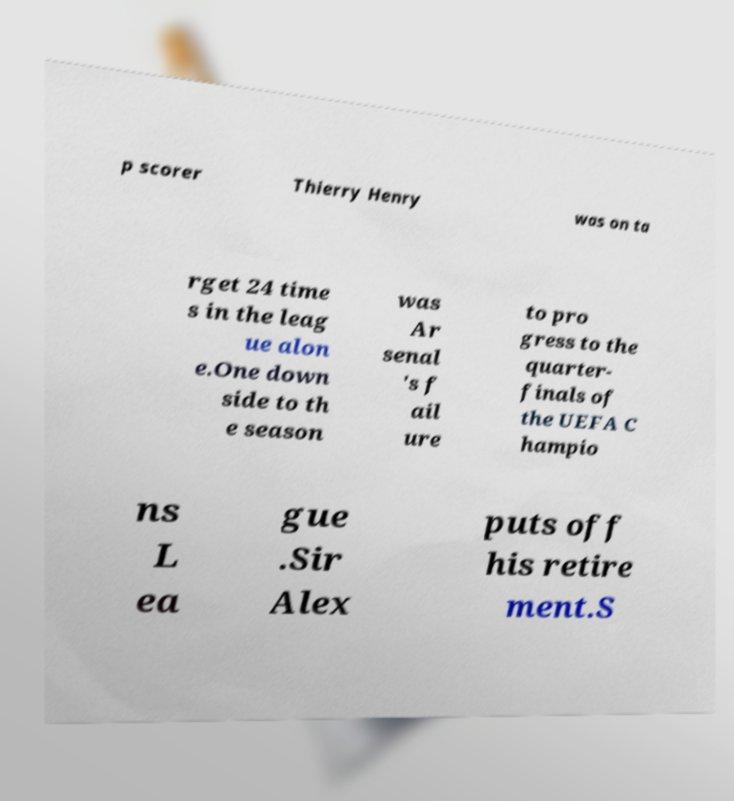Please read and relay the text visible in this image. What does it say? p scorer Thierry Henry was on ta rget 24 time s in the leag ue alon e.One down side to th e season was Ar senal 's f ail ure to pro gress to the quarter- finals of the UEFA C hampio ns L ea gue .Sir Alex puts off his retire ment.S 